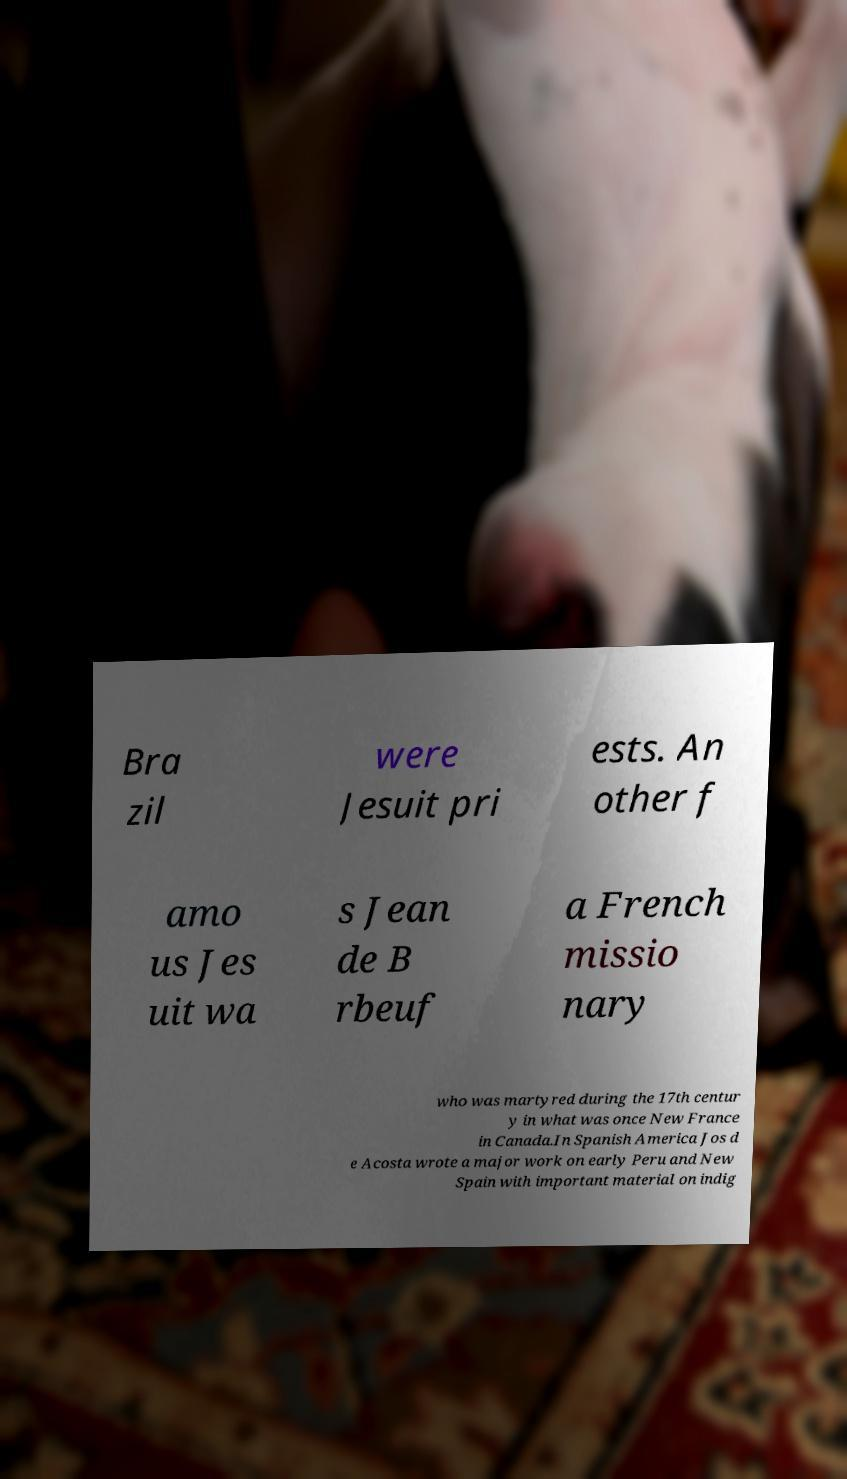Please identify and transcribe the text found in this image. Bra zil were Jesuit pri ests. An other f amo us Jes uit wa s Jean de B rbeuf a French missio nary who was martyred during the 17th centur y in what was once New France in Canada.In Spanish America Jos d e Acosta wrote a major work on early Peru and New Spain with important material on indig 